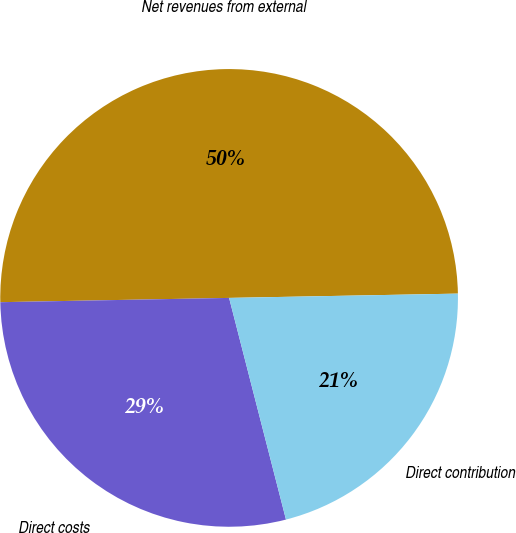Convert chart. <chart><loc_0><loc_0><loc_500><loc_500><pie_chart><fcel>Net revenues from external<fcel>Direct costs<fcel>Direct contribution<nl><fcel>50.0%<fcel>28.7%<fcel>21.3%<nl></chart> 